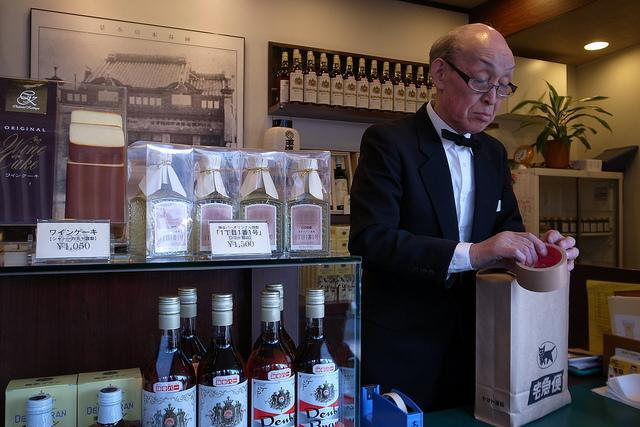What sort of beverages are sold here?

Choices:
A) milk
B) sodas
C) mixers
D) alcoholic alcoholic 